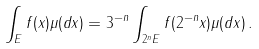<formula> <loc_0><loc_0><loc_500><loc_500>\int _ { E } f ( x ) \mu ( d x ) & = 3 ^ { - n } \int _ { 2 ^ { n } E } f ( 2 ^ { - n } x ) \mu ( d x ) \, .</formula> 